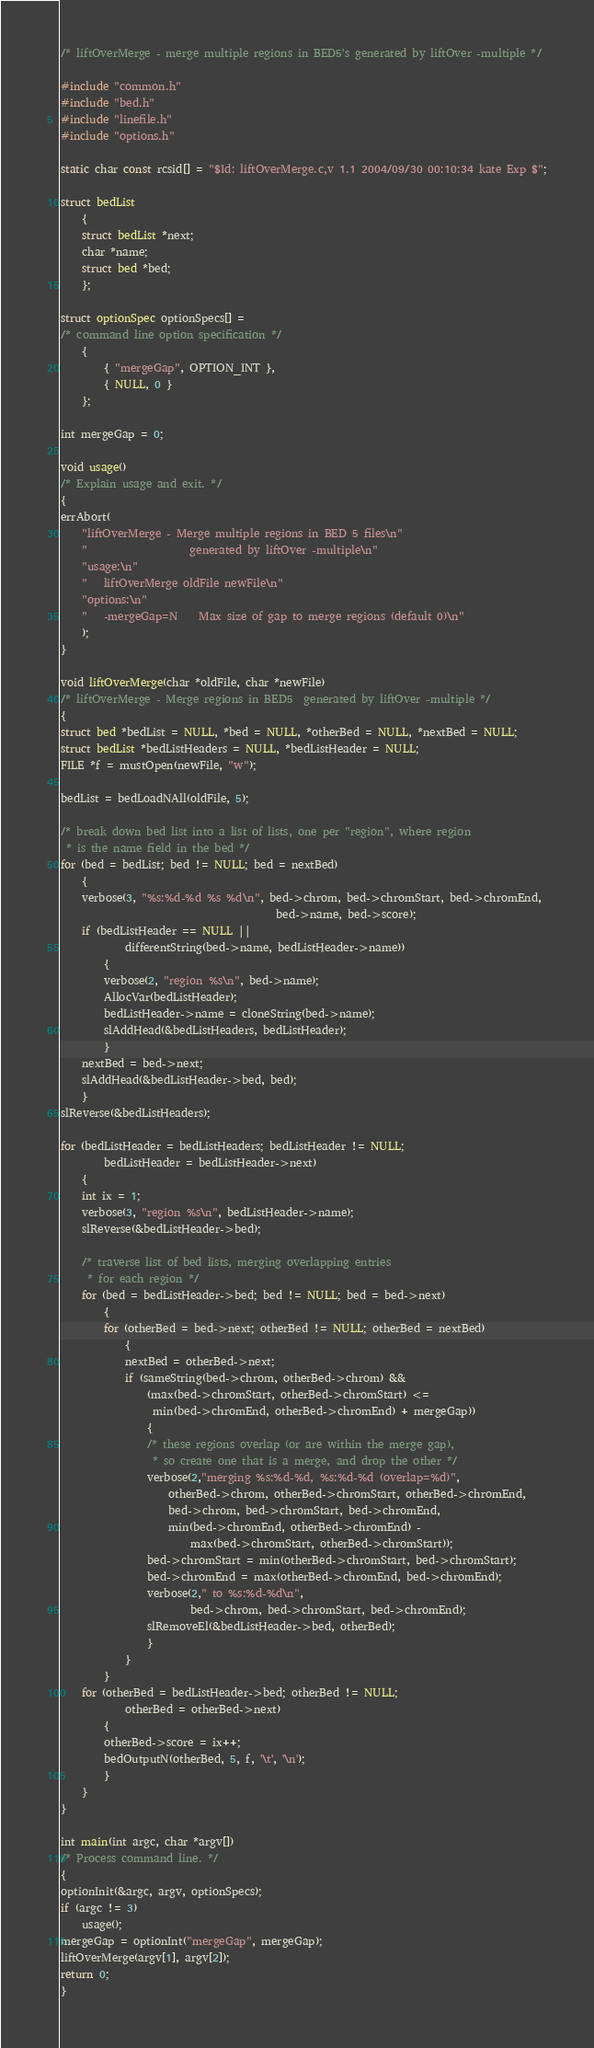Convert code to text. <code><loc_0><loc_0><loc_500><loc_500><_C_>/* liftOverMerge - merge multiple regions in BED5's generated by liftOver -multiple */

#include "common.h"
#include "bed.h"
#include "linefile.h"
#include "options.h"

static char const rcsid[] = "$Id: liftOverMerge.c,v 1.1 2004/09/30 00:10:34 kate Exp $";

struct bedList 
    {
    struct bedList *next;
    char *name;
    struct bed *bed;
    };

struct optionSpec optionSpecs[] =
/* command line option specification */
    {
        { "mergeGap", OPTION_INT },
        { NULL, 0 }
    };

int mergeGap = 0;

void usage()
/* Explain usage and exit. */
{
errAbort(
    "liftOverMerge - Merge multiple regions in BED 5 files\n"
    "                   generated by liftOver -multiple\n"
    "usage:\n"
    "   liftOverMerge oldFile newFile\n"
    "options:\n"
    "   -mergeGap=N    Max size of gap to merge regions (default 0)\n"
    );
}

void liftOverMerge(char *oldFile, char *newFile)
/* liftOverMerge - Merge regions in BED5  generated by liftOver -multiple */
{
struct bed *bedList = NULL, *bed = NULL, *otherBed = NULL, *nextBed = NULL;
struct bedList *bedListHeaders = NULL, *bedListHeader = NULL;
FILE *f = mustOpen(newFile, "w");

bedList = bedLoadNAll(oldFile, 5);

/* break down bed list into a list of lists, one per "region", where region
 * is the name field in the bed */
for (bed = bedList; bed != NULL; bed = nextBed)
    {
    verbose(3, "%s:%d-%d %s %d\n", bed->chrom, bed->chromStart, bed->chromEnd,
                                        bed->name, bed->score);
    if (bedListHeader == NULL || 
            differentString(bed->name, bedListHeader->name))
        {
        verbose(2, "region %s\n", bed->name);
        AllocVar(bedListHeader);
        bedListHeader->name = cloneString(bed->name);
        slAddHead(&bedListHeaders, bedListHeader);
        }
    nextBed = bed->next;
    slAddHead(&bedListHeader->bed, bed);
    }
slReverse(&bedListHeaders);

for (bedListHeader = bedListHeaders; bedListHeader != NULL; 
        bedListHeader = bedListHeader->next)
    {
    int ix = 1;
    verbose(3, "region %s\n", bedListHeader->name);
    slReverse(&bedListHeader->bed);

    /* traverse list of bed lists, merging overlapping entries 
     * for each region */
    for (bed = bedListHeader->bed; bed != NULL; bed = bed->next)
        {
        for (otherBed = bed->next; otherBed != NULL; otherBed = nextBed)
            {
            nextBed = otherBed->next;
            if (sameString(bed->chrom, otherBed->chrom) && 
                (max(bed->chromStart, otherBed->chromStart) <= 
                 min(bed->chromEnd, otherBed->chromEnd) + mergeGap))
                {
                /* these regions overlap (or are within the merge gap),
                 * so create one that is a merge, and drop the other */
                verbose(2,"merging %s:%d-%d, %s:%d-%d (overlap=%d)",
                    otherBed->chrom, otherBed->chromStart, otherBed->chromEnd,
                    bed->chrom, bed->chromStart, bed->chromEnd,
                    min(bed->chromEnd, otherBed->chromEnd) -
                        max(bed->chromStart, otherBed->chromStart)); 
                bed->chromStart = min(otherBed->chromStart, bed->chromStart);
                bed->chromEnd = max(otherBed->chromEnd, bed->chromEnd);
                verbose(2," to %s:%d-%d\n",
                        bed->chrom, bed->chromStart, bed->chromEnd);
                slRemoveEl(&bedListHeader->bed, otherBed);
                }
            }
        }
    for (otherBed = bedListHeader->bed; otherBed != NULL; 
            otherBed = otherBed->next)
        {
        otherBed->score = ix++;
        bedOutputN(otherBed, 5, f, '\t', '\n');
        }
    }
}

int main(int argc, char *argv[])
/* Process command line. */
{
optionInit(&argc, argv, optionSpecs);
if (argc != 3)
    usage();
mergeGap = optionInt("mergeGap", mergeGap);
liftOverMerge(argv[1], argv[2]);
return 0;
}


</code> 